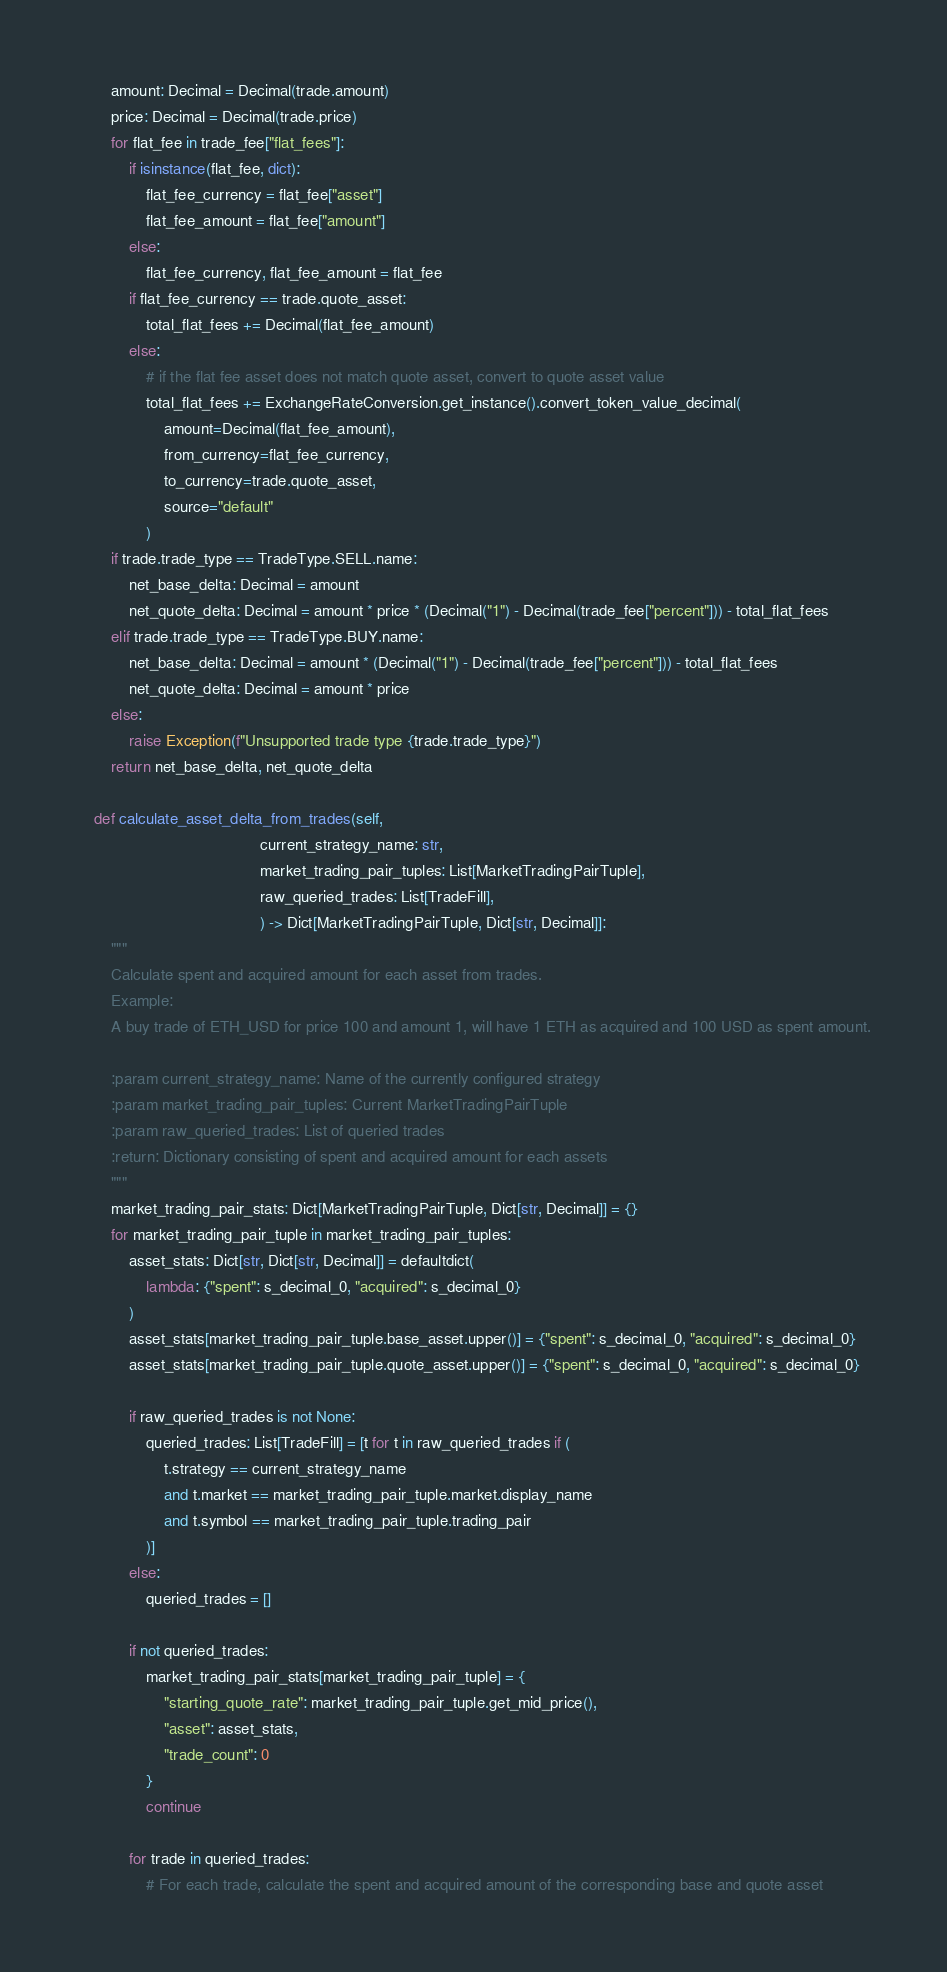<code> <loc_0><loc_0><loc_500><loc_500><_Python_>        amount: Decimal = Decimal(trade.amount)
        price: Decimal = Decimal(trade.price)
        for flat_fee in trade_fee["flat_fees"]:
            if isinstance(flat_fee, dict):
                flat_fee_currency = flat_fee["asset"]
                flat_fee_amount = flat_fee["amount"]
            else:
                flat_fee_currency, flat_fee_amount = flat_fee
            if flat_fee_currency == trade.quote_asset:
                total_flat_fees += Decimal(flat_fee_amount)
            else:
                # if the flat fee asset does not match quote asset, convert to quote asset value
                total_flat_fees += ExchangeRateConversion.get_instance().convert_token_value_decimal(
                    amount=Decimal(flat_fee_amount),
                    from_currency=flat_fee_currency,
                    to_currency=trade.quote_asset,
                    source="default"
                )
        if trade.trade_type == TradeType.SELL.name:
            net_base_delta: Decimal = amount
            net_quote_delta: Decimal = amount * price * (Decimal("1") - Decimal(trade_fee["percent"])) - total_flat_fees
        elif trade.trade_type == TradeType.BUY.name:
            net_base_delta: Decimal = amount * (Decimal("1") - Decimal(trade_fee["percent"])) - total_flat_fees
            net_quote_delta: Decimal = amount * price
        else:
            raise Exception(f"Unsupported trade type {trade.trade_type}")
        return net_base_delta, net_quote_delta

    def calculate_asset_delta_from_trades(self,
                                          current_strategy_name: str,
                                          market_trading_pair_tuples: List[MarketTradingPairTuple],
                                          raw_queried_trades: List[TradeFill],
                                          ) -> Dict[MarketTradingPairTuple, Dict[str, Decimal]]:
        """
        Calculate spent and acquired amount for each asset from trades.
        Example:
        A buy trade of ETH_USD for price 100 and amount 1, will have 1 ETH as acquired and 100 USD as spent amount.

        :param current_strategy_name: Name of the currently configured strategy
        :param market_trading_pair_tuples: Current MarketTradingPairTuple
        :param raw_queried_trades: List of queried trades
        :return: Dictionary consisting of spent and acquired amount for each assets
        """
        market_trading_pair_stats: Dict[MarketTradingPairTuple, Dict[str, Decimal]] = {}
        for market_trading_pair_tuple in market_trading_pair_tuples:
            asset_stats: Dict[str, Dict[str, Decimal]] = defaultdict(
                lambda: {"spent": s_decimal_0, "acquired": s_decimal_0}
            )
            asset_stats[market_trading_pair_tuple.base_asset.upper()] = {"spent": s_decimal_0, "acquired": s_decimal_0}
            asset_stats[market_trading_pair_tuple.quote_asset.upper()] = {"spent": s_decimal_0, "acquired": s_decimal_0}

            if raw_queried_trades is not None:
                queried_trades: List[TradeFill] = [t for t in raw_queried_trades if (
                    t.strategy == current_strategy_name
                    and t.market == market_trading_pair_tuple.market.display_name
                    and t.symbol == market_trading_pair_tuple.trading_pair
                )]
            else:
                queried_trades = []

            if not queried_trades:
                market_trading_pair_stats[market_trading_pair_tuple] = {
                    "starting_quote_rate": market_trading_pair_tuple.get_mid_price(),
                    "asset": asset_stats,
                    "trade_count": 0
                }
                continue

            for trade in queried_trades:
                # For each trade, calculate the spent and acquired amount of the corresponding base and quote asset</code> 